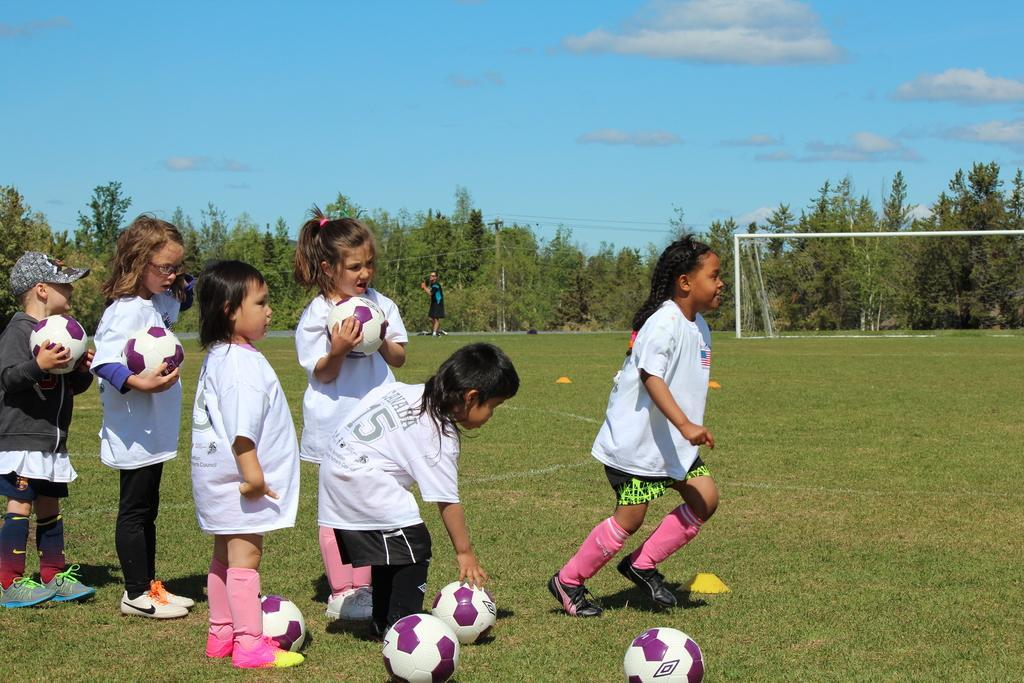Please provide a concise description of this image. in a ground people are standing in a line, holding a ball in their hand. the person in the front is running. behind them there is a person standing. at the back there is a net and trees. there are few clouds in the sky. 